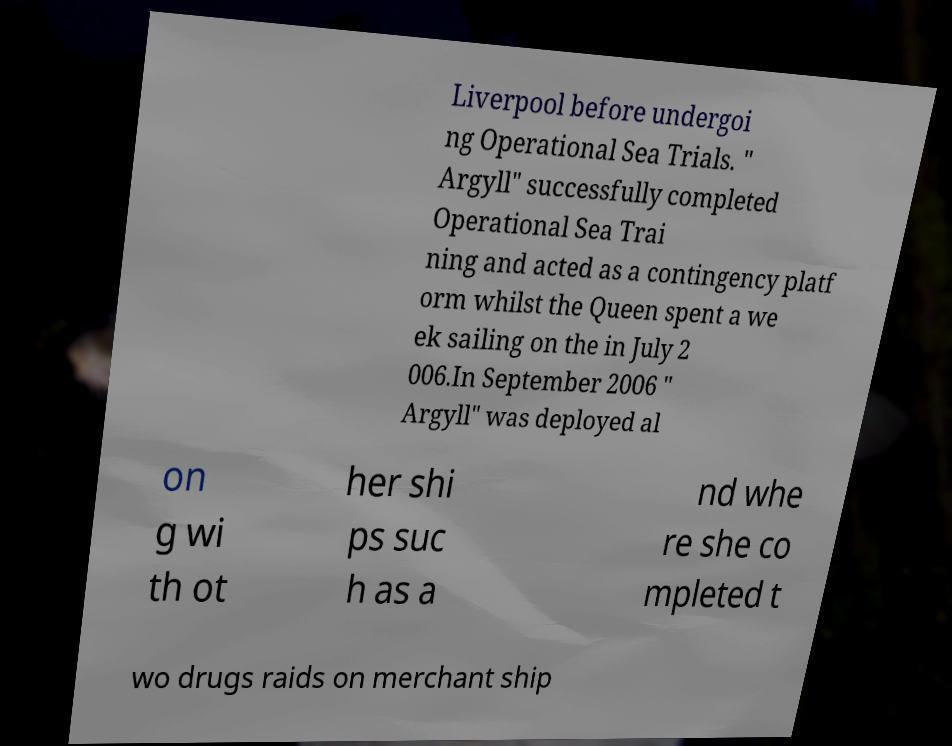For documentation purposes, I need the text within this image transcribed. Could you provide that? Liverpool before undergoi ng Operational Sea Trials. " Argyll" successfully completed Operational Sea Trai ning and acted as a contingency platf orm whilst the Queen spent a we ek sailing on the in July 2 006.In September 2006 " Argyll" was deployed al on g wi th ot her shi ps suc h as a nd whe re she co mpleted t wo drugs raids on merchant ship 